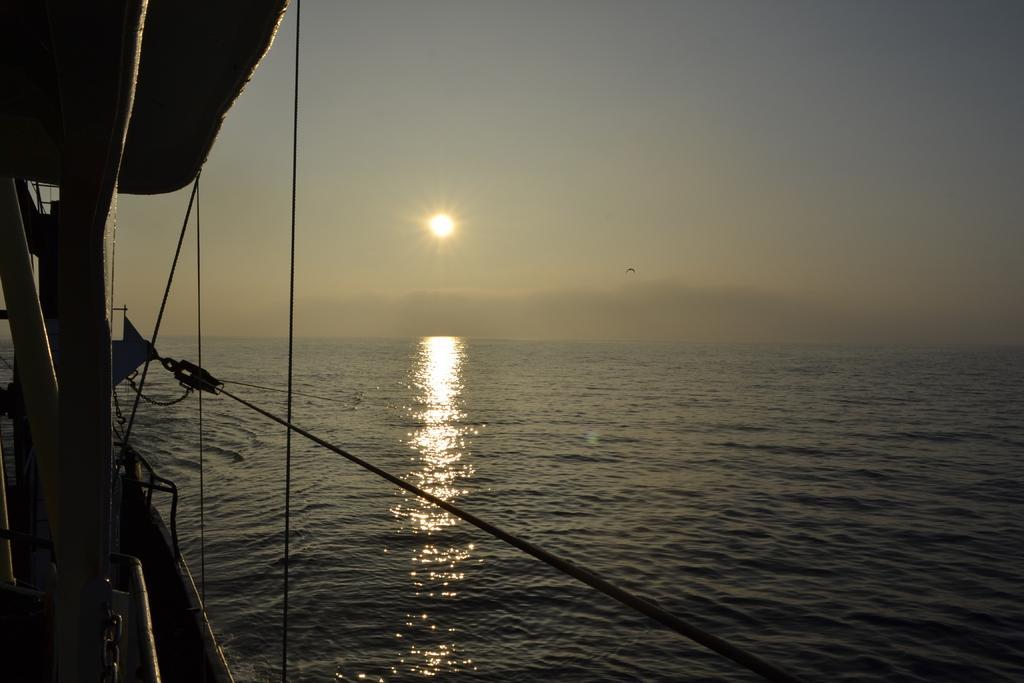In one or two sentences, can you explain what this image depicts? On the left side of the image we can see a boat, ropes. In the background of the image we can see the water. At the top of the image we can see a bird, sun, sky. 